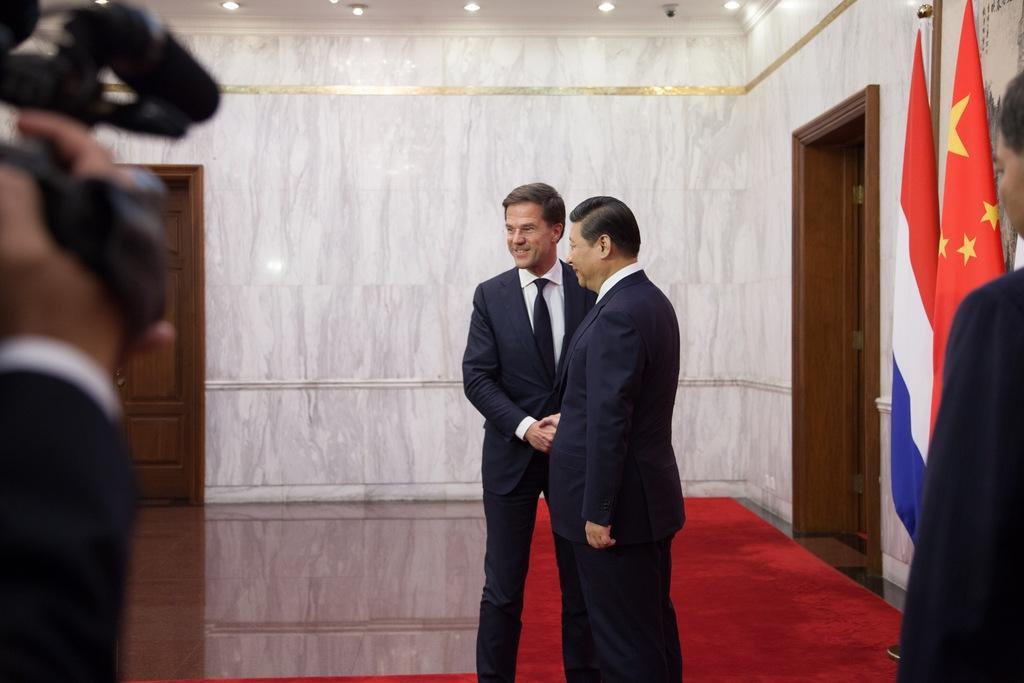Please provide a concise description of this image. This picture describes about group of people, on the left side of the image we can see a person is holding a camera, on the right side of the image we can find few flags on the wall, in the background we can see lights. 